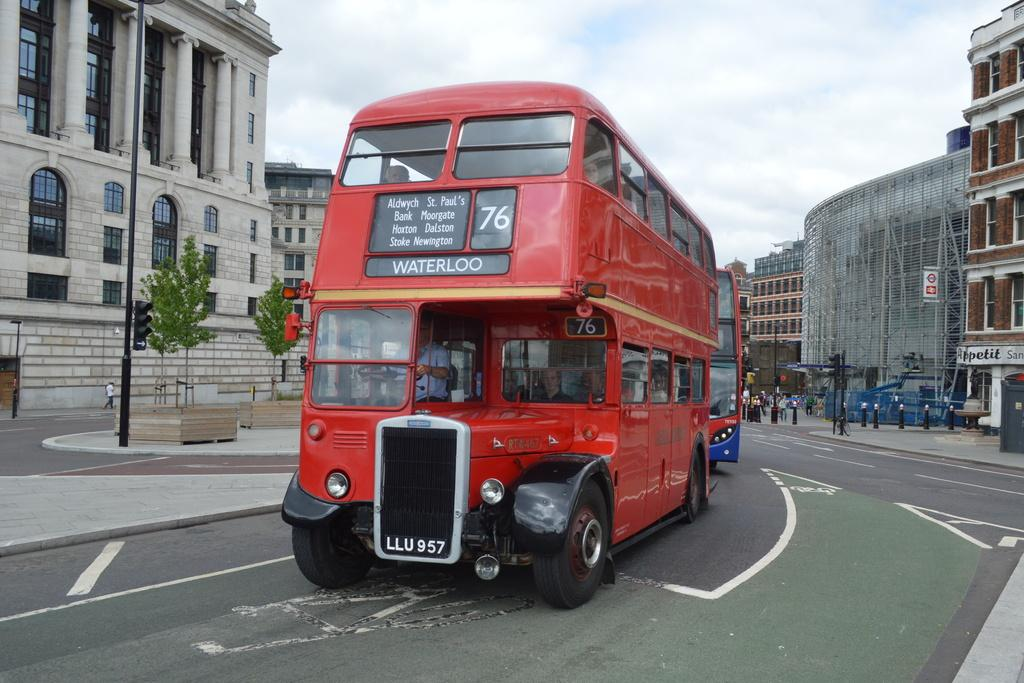What is the main structure in the middle of the image? There is a building in the middle of the image. What else can be seen in the middle of the image besides the building? There is a red bus in the middle of the image. What type of vegetation is on the left side of the image? There are trees on the left side of the image. What is visible at the top of the image? The sky is visible at the top of the image. How many cars are parked in front of the building in the image? There is no mention of cars in the image; only a building and a red bus are present. What type of van can be seen driving through the trees on the left side of the image? There is no van present in the image; only trees are visible on the left side. 